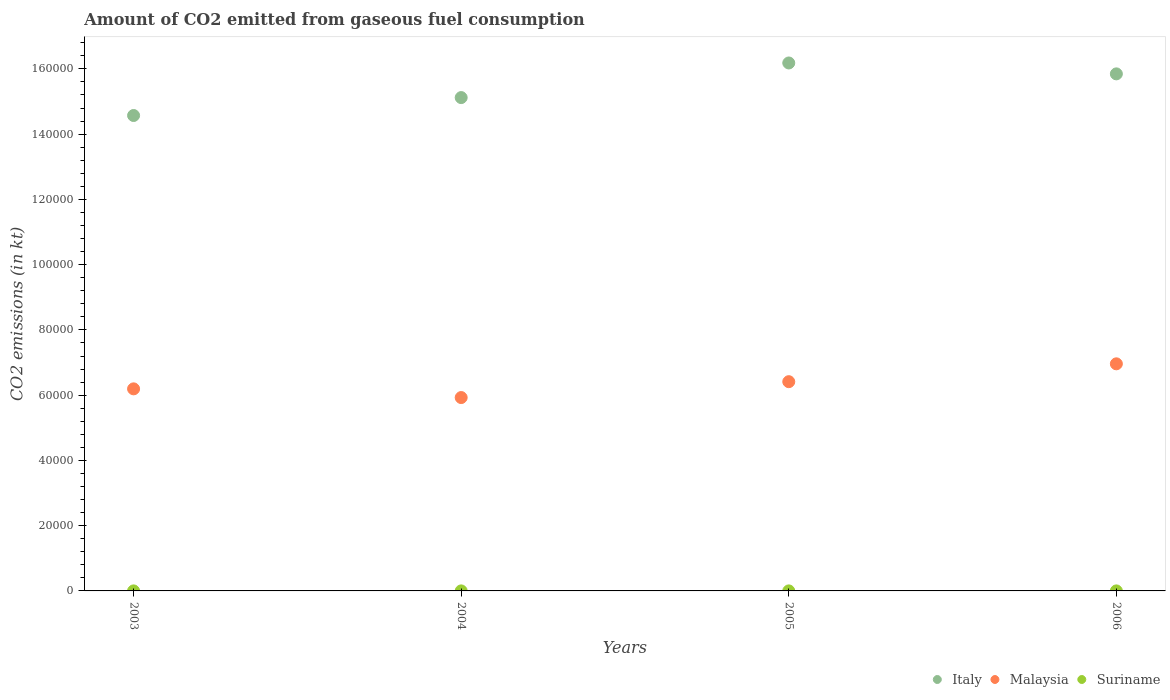How many different coloured dotlines are there?
Provide a short and direct response. 3. What is the amount of CO2 emitted in Suriname in 2004?
Give a very brief answer. 7.33. Across all years, what is the maximum amount of CO2 emitted in Malaysia?
Provide a short and direct response. 6.96e+04. Across all years, what is the minimum amount of CO2 emitted in Suriname?
Give a very brief answer. 7.33. What is the total amount of CO2 emitted in Suriname in the graph?
Make the answer very short. 29.34. What is the difference between the amount of CO2 emitted in Italy in 2003 and that in 2005?
Your answer should be compact. -1.61e+04. What is the difference between the amount of CO2 emitted in Suriname in 2004 and the amount of CO2 emitted in Italy in 2005?
Keep it short and to the point. -1.62e+05. What is the average amount of CO2 emitted in Malaysia per year?
Provide a short and direct response. 6.37e+04. In the year 2006, what is the difference between the amount of CO2 emitted in Italy and amount of CO2 emitted in Suriname?
Provide a succinct answer. 1.58e+05. In how many years, is the amount of CO2 emitted in Malaysia greater than 52000 kt?
Provide a short and direct response. 4. What is the ratio of the amount of CO2 emitted in Malaysia in 2003 to that in 2004?
Keep it short and to the point. 1.04. Is the amount of CO2 emitted in Suriname in 2004 less than that in 2006?
Your response must be concise. No. Is the difference between the amount of CO2 emitted in Italy in 2004 and 2006 greater than the difference between the amount of CO2 emitted in Suriname in 2004 and 2006?
Keep it short and to the point. No. What is the difference between the highest and the second highest amount of CO2 emitted in Italy?
Your response must be concise. 3340.64. What is the difference between the highest and the lowest amount of CO2 emitted in Malaysia?
Your answer should be compact. 1.03e+04. In how many years, is the amount of CO2 emitted in Malaysia greater than the average amount of CO2 emitted in Malaysia taken over all years?
Offer a very short reply. 2. Is it the case that in every year, the sum of the amount of CO2 emitted in Italy and amount of CO2 emitted in Malaysia  is greater than the amount of CO2 emitted in Suriname?
Your answer should be very brief. Yes. Does the amount of CO2 emitted in Malaysia monotonically increase over the years?
Provide a succinct answer. No. Is the amount of CO2 emitted in Malaysia strictly less than the amount of CO2 emitted in Italy over the years?
Your answer should be compact. Yes. How many years are there in the graph?
Your answer should be very brief. 4. What is the difference between two consecutive major ticks on the Y-axis?
Make the answer very short. 2.00e+04. Does the graph contain grids?
Keep it short and to the point. No. Where does the legend appear in the graph?
Provide a succinct answer. Bottom right. How many legend labels are there?
Give a very brief answer. 3. What is the title of the graph?
Offer a terse response. Amount of CO2 emitted from gaseous fuel consumption. What is the label or title of the X-axis?
Your answer should be very brief. Years. What is the label or title of the Y-axis?
Give a very brief answer. CO2 emissions (in kt). What is the CO2 emissions (in kt) of Italy in 2003?
Provide a succinct answer. 1.46e+05. What is the CO2 emissions (in kt) in Malaysia in 2003?
Make the answer very short. 6.19e+04. What is the CO2 emissions (in kt) of Suriname in 2003?
Your answer should be compact. 7.33. What is the CO2 emissions (in kt) of Italy in 2004?
Your answer should be compact. 1.51e+05. What is the CO2 emissions (in kt) in Malaysia in 2004?
Provide a short and direct response. 5.93e+04. What is the CO2 emissions (in kt) of Suriname in 2004?
Give a very brief answer. 7.33. What is the CO2 emissions (in kt) in Italy in 2005?
Ensure brevity in your answer.  1.62e+05. What is the CO2 emissions (in kt) in Malaysia in 2005?
Your response must be concise. 6.41e+04. What is the CO2 emissions (in kt) in Suriname in 2005?
Provide a short and direct response. 7.33. What is the CO2 emissions (in kt) of Italy in 2006?
Give a very brief answer. 1.58e+05. What is the CO2 emissions (in kt) of Malaysia in 2006?
Offer a terse response. 6.96e+04. What is the CO2 emissions (in kt) of Suriname in 2006?
Give a very brief answer. 7.33. Across all years, what is the maximum CO2 emissions (in kt) in Italy?
Make the answer very short. 1.62e+05. Across all years, what is the maximum CO2 emissions (in kt) in Malaysia?
Provide a short and direct response. 6.96e+04. Across all years, what is the maximum CO2 emissions (in kt) of Suriname?
Offer a terse response. 7.33. Across all years, what is the minimum CO2 emissions (in kt) in Italy?
Give a very brief answer. 1.46e+05. Across all years, what is the minimum CO2 emissions (in kt) of Malaysia?
Your response must be concise. 5.93e+04. Across all years, what is the minimum CO2 emissions (in kt) of Suriname?
Your response must be concise. 7.33. What is the total CO2 emissions (in kt) in Italy in the graph?
Ensure brevity in your answer.  6.17e+05. What is the total CO2 emissions (in kt) of Malaysia in the graph?
Your answer should be very brief. 2.55e+05. What is the total CO2 emissions (in kt) in Suriname in the graph?
Offer a very short reply. 29.34. What is the difference between the CO2 emissions (in kt) in Italy in 2003 and that in 2004?
Ensure brevity in your answer.  -5493.17. What is the difference between the CO2 emissions (in kt) in Malaysia in 2003 and that in 2004?
Offer a very short reply. 2665.91. What is the difference between the CO2 emissions (in kt) in Suriname in 2003 and that in 2004?
Your response must be concise. 0. What is the difference between the CO2 emissions (in kt) of Italy in 2003 and that in 2005?
Ensure brevity in your answer.  -1.61e+04. What is the difference between the CO2 emissions (in kt) of Malaysia in 2003 and that in 2005?
Offer a very short reply. -2200.2. What is the difference between the CO2 emissions (in kt) in Italy in 2003 and that in 2006?
Your response must be concise. -1.28e+04. What is the difference between the CO2 emissions (in kt) in Malaysia in 2003 and that in 2006?
Your response must be concise. -7671.36. What is the difference between the CO2 emissions (in kt) of Italy in 2004 and that in 2005?
Keep it short and to the point. -1.06e+04. What is the difference between the CO2 emissions (in kt) in Malaysia in 2004 and that in 2005?
Give a very brief answer. -4866.11. What is the difference between the CO2 emissions (in kt) in Italy in 2004 and that in 2006?
Make the answer very short. -7267.99. What is the difference between the CO2 emissions (in kt) of Malaysia in 2004 and that in 2006?
Give a very brief answer. -1.03e+04. What is the difference between the CO2 emissions (in kt) of Suriname in 2004 and that in 2006?
Offer a very short reply. 0. What is the difference between the CO2 emissions (in kt) in Italy in 2005 and that in 2006?
Give a very brief answer. 3340.64. What is the difference between the CO2 emissions (in kt) of Malaysia in 2005 and that in 2006?
Make the answer very short. -5471.16. What is the difference between the CO2 emissions (in kt) of Italy in 2003 and the CO2 emissions (in kt) of Malaysia in 2004?
Give a very brief answer. 8.64e+04. What is the difference between the CO2 emissions (in kt) of Italy in 2003 and the CO2 emissions (in kt) of Suriname in 2004?
Provide a short and direct response. 1.46e+05. What is the difference between the CO2 emissions (in kt) of Malaysia in 2003 and the CO2 emissions (in kt) of Suriname in 2004?
Your answer should be compact. 6.19e+04. What is the difference between the CO2 emissions (in kt) of Italy in 2003 and the CO2 emissions (in kt) of Malaysia in 2005?
Provide a short and direct response. 8.16e+04. What is the difference between the CO2 emissions (in kt) of Italy in 2003 and the CO2 emissions (in kt) of Suriname in 2005?
Your answer should be very brief. 1.46e+05. What is the difference between the CO2 emissions (in kt) of Malaysia in 2003 and the CO2 emissions (in kt) of Suriname in 2005?
Your answer should be compact. 6.19e+04. What is the difference between the CO2 emissions (in kt) in Italy in 2003 and the CO2 emissions (in kt) in Malaysia in 2006?
Your answer should be very brief. 7.61e+04. What is the difference between the CO2 emissions (in kt) in Italy in 2003 and the CO2 emissions (in kt) in Suriname in 2006?
Make the answer very short. 1.46e+05. What is the difference between the CO2 emissions (in kt) of Malaysia in 2003 and the CO2 emissions (in kt) of Suriname in 2006?
Your response must be concise. 6.19e+04. What is the difference between the CO2 emissions (in kt) in Italy in 2004 and the CO2 emissions (in kt) in Malaysia in 2005?
Offer a terse response. 8.71e+04. What is the difference between the CO2 emissions (in kt) in Italy in 2004 and the CO2 emissions (in kt) in Suriname in 2005?
Make the answer very short. 1.51e+05. What is the difference between the CO2 emissions (in kt) of Malaysia in 2004 and the CO2 emissions (in kt) of Suriname in 2005?
Give a very brief answer. 5.93e+04. What is the difference between the CO2 emissions (in kt) of Italy in 2004 and the CO2 emissions (in kt) of Malaysia in 2006?
Offer a terse response. 8.16e+04. What is the difference between the CO2 emissions (in kt) in Italy in 2004 and the CO2 emissions (in kt) in Suriname in 2006?
Ensure brevity in your answer.  1.51e+05. What is the difference between the CO2 emissions (in kt) of Malaysia in 2004 and the CO2 emissions (in kt) of Suriname in 2006?
Provide a succinct answer. 5.93e+04. What is the difference between the CO2 emissions (in kt) of Italy in 2005 and the CO2 emissions (in kt) of Malaysia in 2006?
Your response must be concise. 9.22e+04. What is the difference between the CO2 emissions (in kt) of Italy in 2005 and the CO2 emissions (in kt) of Suriname in 2006?
Offer a very short reply. 1.62e+05. What is the difference between the CO2 emissions (in kt) in Malaysia in 2005 and the CO2 emissions (in kt) in Suriname in 2006?
Your answer should be very brief. 6.41e+04. What is the average CO2 emissions (in kt) of Italy per year?
Keep it short and to the point. 1.54e+05. What is the average CO2 emissions (in kt) of Malaysia per year?
Provide a succinct answer. 6.37e+04. What is the average CO2 emissions (in kt) of Suriname per year?
Offer a very short reply. 7.33. In the year 2003, what is the difference between the CO2 emissions (in kt) of Italy and CO2 emissions (in kt) of Malaysia?
Give a very brief answer. 8.38e+04. In the year 2003, what is the difference between the CO2 emissions (in kt) of Italy and CO2 emissions (in kt) of Suriname?
Ensure brevity in your answer.  1.46e+05. In the year 2003, what is the difference between the CO2 emissions (in kt) of Malaysia and CO2 emissions (in kt) of Suriname?
Offer a terse response. 6.19e+04. In the year 2004, what is the difference between the CO2 emissions (in kt) of Italy and CO2 emissions (in kt) of Malaysia?
Your response must be concise. 9.19e+04. In the year 2004, what is the difference between the CO2 emissions (in kt) in Italy and CO2 emissions (in kt) in Suriname?
Ensure brevity in your answer.  1.51e+05. In the year 2004, what is the difference between the CO2 emissions (in kt) in Malaysia and CO2 emissions (in kt) in Suriname?
Keep it short and to the point. 5.93e+04. In the year 2005, what is the difference between the CO2 emissions (in kt) in Italy and CO2 emissions (in kt) in Malaysia?
Make the answer very short. 9.77e+04. In the year 2005, what is the difference between the CO2 emissions (in kt) in Italy and CO2 emissions (in kt) in Suriname?
Offer a terse response. 1.62e+05. In the year 2005, what is the difference between the CO2 emissions (in kt) of Malaysia and CO2 emissions (in kt) of Suriname?
Provide a short and direct response. 6.41e+04. In the year 2006, what is the difference between the CO2 emissions (in kt) in Italy and CO2 emissions (in kt) in Malaysia?
Offer a very short reply. 8.89e+04. In the year 2006, what is the difference between the CO2 emissions (in kt) in Italy and CO2 emissions (in kt) in Suriname?
Give a very brief answer. 1.58e+05. In the year 2006, what is the difference between the CO2 emissions (in kt) in Malaysia and CO2 emissions (in kt) in Suriname?
Your answer should be very brief. 6.96e+04. What is the ratio of the CO2 emissions (in kt) of Italy in 2003 to that in 2004?
Your answer should be very brief. 0.96. What is the ratio of the CO2 emissions (in kt) in Malaysia in 2003 to that in 2004?
Make the answer very short. 1.04. What is the ratio of the CO2 emissions (in kt) in Suriname in 2003 to that in 2004?
Ensure brevity in your answer.  1. What is the ratio of the CO2 emissions (in kt) in Italy in 2003 to that in 2005?
Keep it short and to the point. 0.9. What is the ratio of the CO2 emissions (in kt) of Malaysia in 2003 to that in 2005?
Provide a short and direct response. 0.97. What is the ratio of the CO2 emissions (in kt) in Suriname in 2003 to that in 2005?
Your answer should be very brief. 1. What is the ratio of the CO2 emissions (in kt) of Italy in 2003 to that in 2006?
Offer a very short reply. 0.92. What is the ratio of the CO2 emissions (in kt) of Malaysia in 2003 to that in 2006?
Your response must be concise. 0.89. What is the ratio of the CO2 emissions (in kt) of Italy in 2004 to that in 2005?
Offer a very short reply. 0.93. What is the ratio of the CO2 emissions (in kt) in Malaysia in 2004 to that in 2005?
Ensure brevity in your answer.  0.92. What is the ratio of the CO2 emissions (in kt) of Italy in 2004 to that in 2006?
Your response must be concise. 0.95. What is the ratio of the CO2 emissions (in kt) in Malaysia in 2004 to that in 2006?
Ensure brevity in your answer.  0.85. What is the ratio of the CO2 emissions (in kt) of Italy in 2005 to that in 2006?
Provide a short and direct response. 1.02. What is the ratio of the CO2 emissions (in kt) in Malaysia in 2005 to that in 2006?
Provide a short and direct response. 0.92. What is the ratio of the CO2 emissions (in kt) of Suriname in 2005 to that in 2006?
Offer a terse response. 1. What is the difference between the highest and the second highest CO2 emissions (in kt) of Italy?
Offer a terse response. 3340.64. What is the difference between the highest and the second highest CO2 emissions (in kt) of Malaysia?
Offer a very short reply. 5471.16. What is the difference between the highest and the second highest CO2 emissions (in kt) of Suriname?
Make the answer very short. 0. What is the difference between the highest and the lowest CO2 emissions (in kt) of Italy?
Provide a succinct answer. 1.61e+04. What is the difference between the highest and the lowest CO2 emissions (in kt) in Malaysia?
Your answer should be compact. 1.03e+04. What is the difference between the highest and the lowest CO2 emissions (in kt) in Suriname?
Ensure brevity in your answer.  0. 